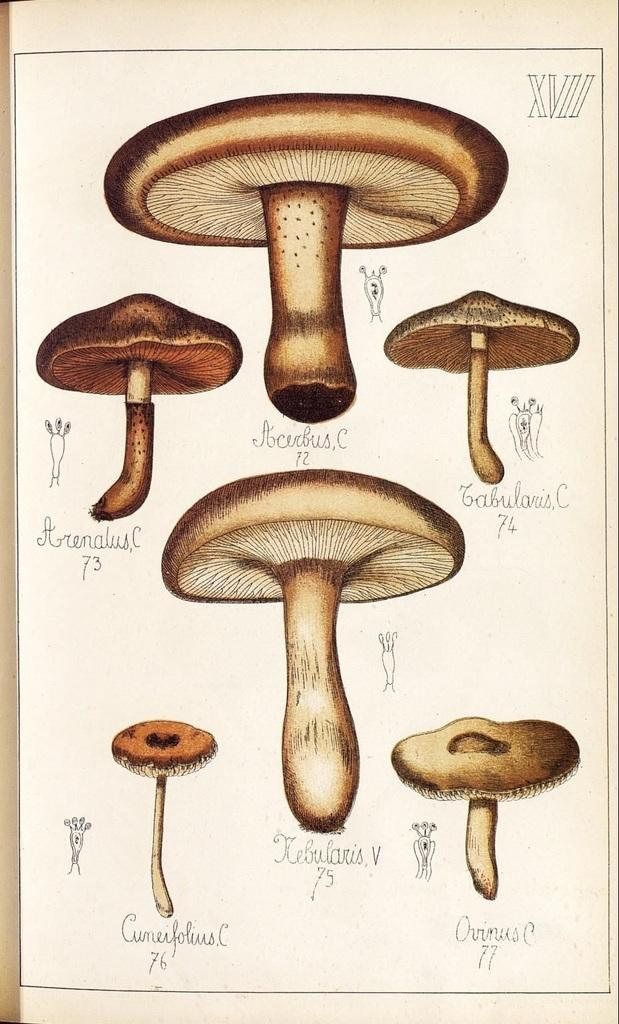What type of fungi can be seen in the image? There are mushrooms in the image. What color are the mushrooms? The mushrooms are brown in color. What else is present in the image besides the mushrooms? There is a paper with writing on it in the image. Can you tell me how many crates are stacked next to the mushrooms in the image? There are no crates present in the image; it only features mushrooms and a paper with writing on it. What role does the grandfather play in the image? There is no mention of a grandfather or any person in the image; it only features mushrooms and a paper with writing on it. 